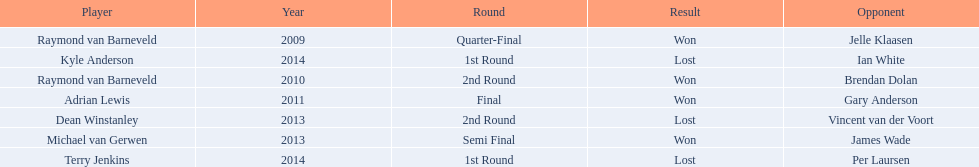What players competed in the pdc world darts championship? Raymond van Barneveld, Raymond van Barneveld, Adrian Lewis, Dean Winstanley, Michael van Gerwen, Terry Jenkins, Kyle Anderson. Of these players, who lost? Dean Winstanley, Terry Jenkins, Kyle Anderson. Which of these players lost in 2014? Terry Jenkins, Kyle Anderson. What are the players other than kyle anderson? Terry Jenkins. 